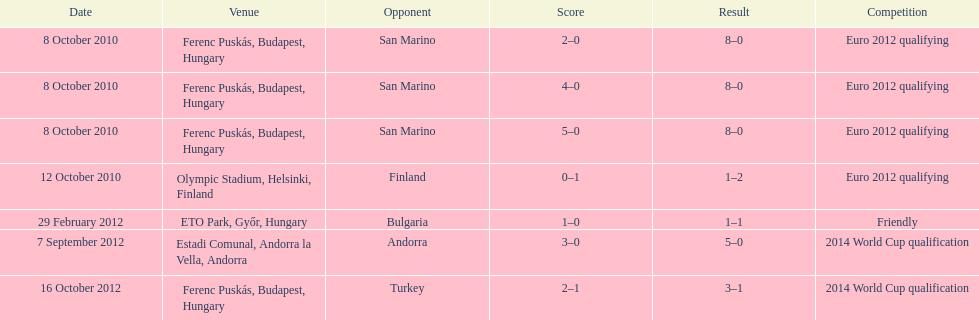How many consecutive games were goals were against san marino? 3. 